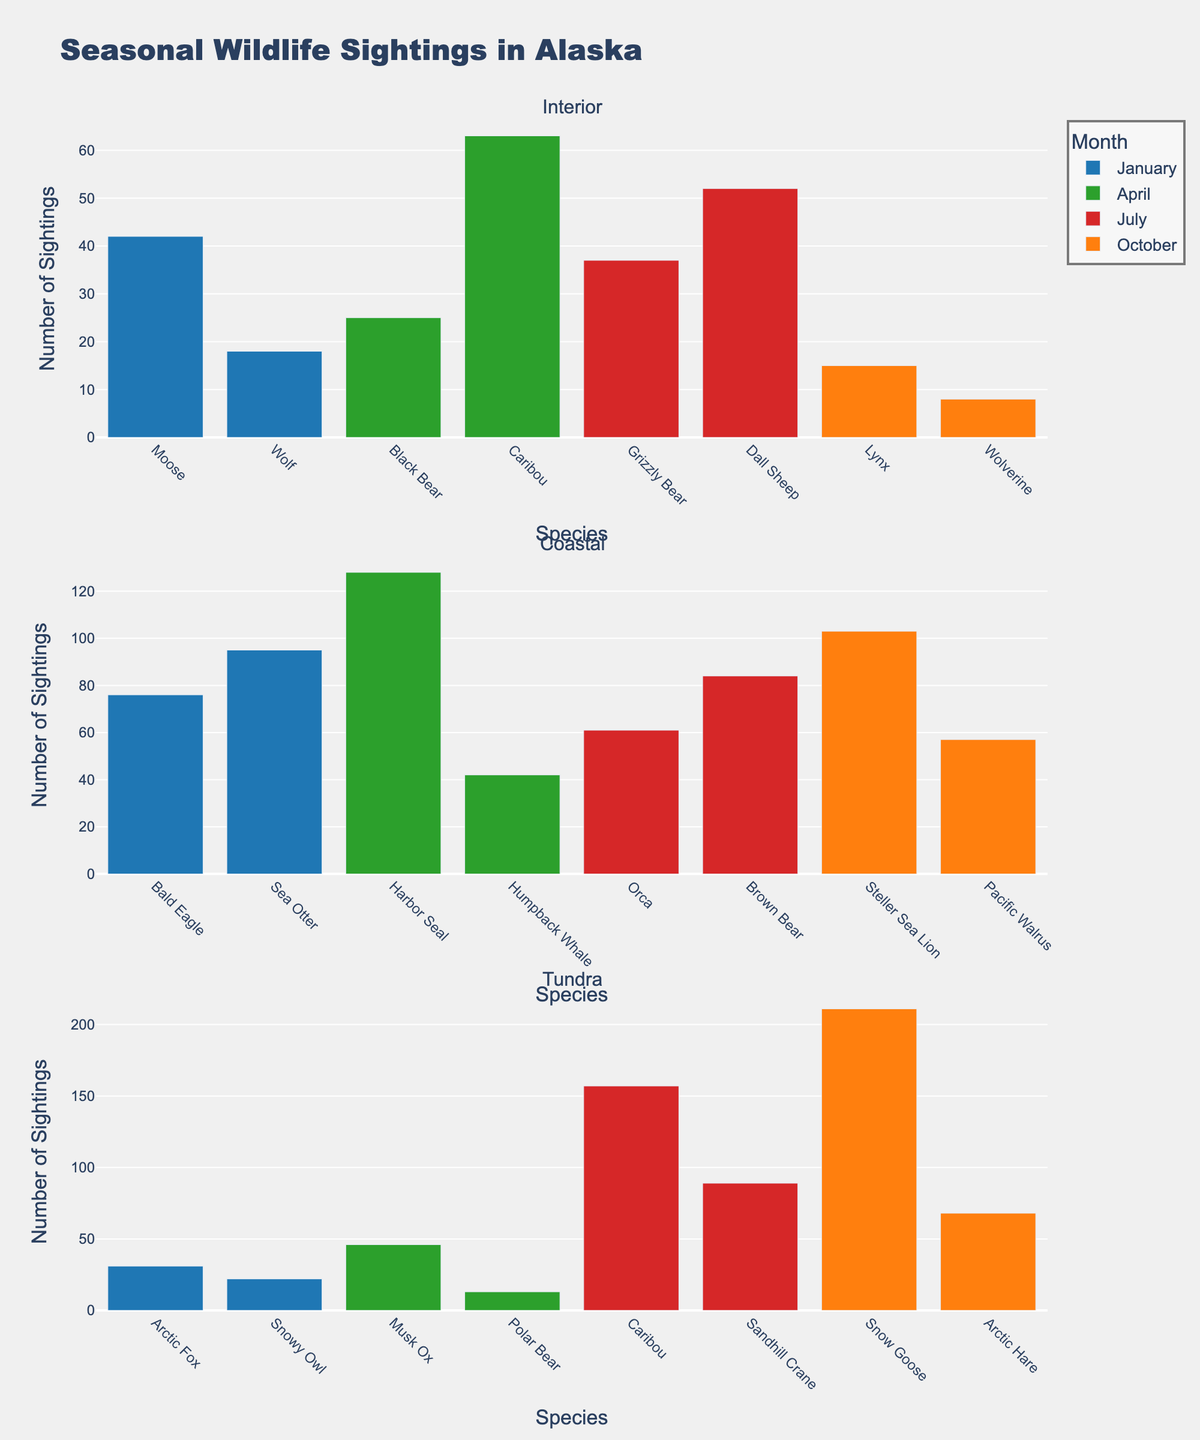what is the title of the figure? The title of the figure is usually placed at the top and can be read directly. In this figure, the title is "Seasonal Wildlife Sightings in Alaska".
Answer: Seasonal Wildlife Sightings in Alaska how many regions are compared in the figure? To determine the number of regions, you count the number of subplots, each of which represents a different region. Here, there are three subplots, indicating three regions are compared.
Answer: 3 which species has the highest number of sightings in July in the Tundra region? Look at the bar heights for July within the Tundra subplot to see which species has the tallest bar. Caribou has the tallest bar, indicating the highest sightings.
Answer: Caribou how many species were sighted in April across all regions? Add the number of species observed in April for each region. In the Interior region, 2 species; in Coastal, 2 species; and in Tundra, 2 species, totaling 6 species.
Answer: 6 which month has the least sightings of species in the Interior region? Examine the bar heights in the Interior subplot to identify the month with the shortest total bar heights. October has the least sightings with the Lynx and Wolverine adding up to the smallest total.
Answer: October compare the sighting of the Grizzly Bear in the Interior region in July and the Brown Bear in the Coastal region in July. Which has more sightings? Compare the heights of the bars for the Grizzly Bear in July in the Interior subplot and for the Brown Bear in July in the Coastal subplot. The Brown Bear in the Coastal region has a taller bar indicating more sightings.
Answer: Brown Bear which species were sighted more than 200 times in a single month in the Tundra region? Look for a species in the Tundra subplot that has a bar taller than 200 in the y-axis. The Snow Goose in October exceeds this height, with 211 sightings.
Answer: Snow Goose add up all the sightings of Bald Eagle in January across all regions. Bald Eagles are only recorded in the Coastal region in January. The number of sightings there is 76. Thus, the total is 76.
Answer: 76 are there more sightings of Snowy Owl or Arctic Hare in January in the Tundra region? Compare the bar heights for Snowy Owl and Arctic Hare in January in the Tundra subplot. The Snowy Owl has 22 sightings and the Arctic Hare has 0 in January.
Answer: Snowy Owl which region has the widest range of species observed over the year? Count the number of unique species bars across the subplots for each region. The Tundra region has the widest range with 8 distinct species observed over the year.
Answer: Tundra 